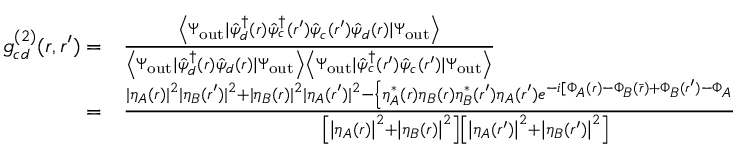Convert formula to latex. <formula><loc_0><loc_0><loc_500><loc_500>\begin{array} { r l } { g _ { c d } ^ { ( 2 ) } ( r , r ^ { \prime } ) = } & \frac { \left \langle \Psi _ { o u t } | \hat { \psi } _ { d } ^ { \dagger } ( r ) \hat { \psi } _ { c } ^ { \dagger } ( r ^ { \prime } ) \hat { \psi } _ { c } ( r ^ { \prime } ) \hat { \psi } _ { d } ( r ) | \Psi _ { o u t } \right \rangle } { \left \langle \Psi _ { o u t } | \hat { \psi } _ { d } ^ { \dagger } ( r ) \hat { \psi } _ { d } ( r ) | \Psi _ { o u t } \right \rangle \left \langle \Psi _ { o u t } | \hat { \psi } _ { c } ^ { \dagger } ( r ^ { \prime } ) \hat { \psi } _ { c } ( r ^ { \prime } ) | \Psi _ { o u t } \right \rangle } } \\ { = } & \frac { | \eta _ { A } ( r ) | ^ { 2 } | \eta _ { B } ( r ^ { \prime } ) | ^ { 2 } + | \eta _ { B } ( r ) | ^ { 2 } | \eta _ { A } ( r ^ { \prime } ) | ^ { 2 } - \left \{ \eta _ { A } ^ { * } ( r ) \eta _ { B } ( r ) \eta _ { B } ^ { * } ( r ^ { \prime } ) \eta _ { A } ( r ^ { \prime } ) e ^ { - i [ \Phi _ { A } ( r ) - \Phi _ { B } ( \bar { r } ) + \Phi _ { B } ( r ^ { \prime } ) - \Phi _ { A } ( \bar { r } ^ { \prime } ) ] } + c . c . \right \} } { \left [ \left | \eta _ { A } ( r ) \right | ^ { 2 } + \left | \eta _ { B } ( r ) \right | ^ { 2 } \right ] \left [ \left | \eta _ { A } ( r ^ { \prime } ) \right | ^ { 2 } + \left | \eta _ { B } ( r ^ { \prime } ) \right | ^ { 2 } \right ] } , } \end{array}</formula> 